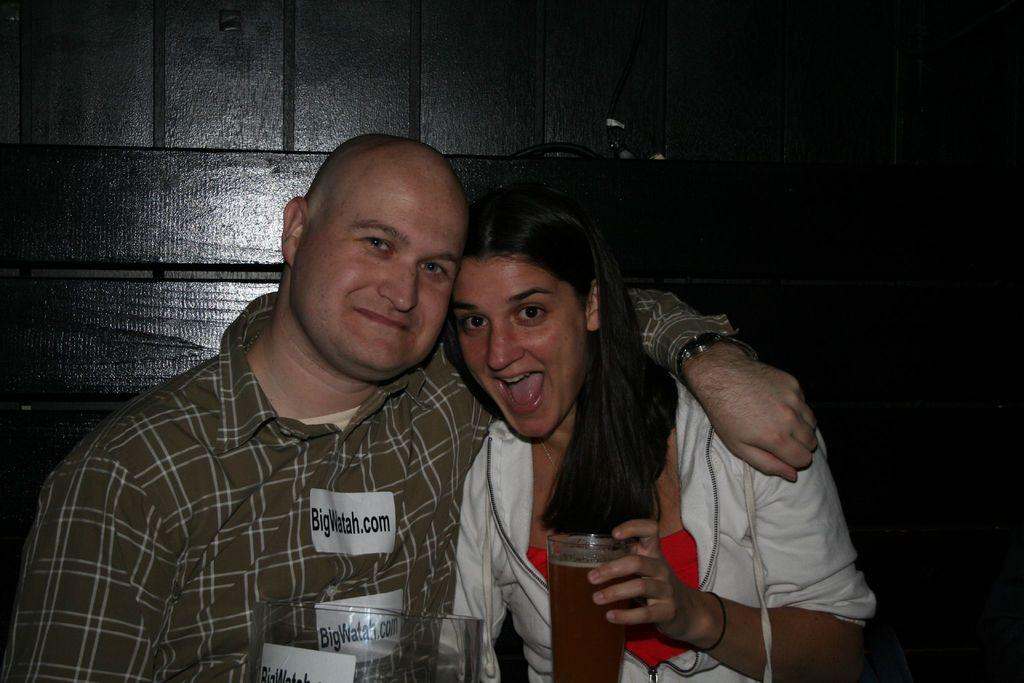How many people are present in the image? There are two persons in the image. What can be seen in the image besides the people? There is a glass and other objects visible in the image. What type of objects can be seen in the background of the image? There are wooden objects and a wall in the background of the image. Can you describe the unspecified object in the background? Unfortunately, the fact provided does not give enough information to describe the unspecified object in the background. What is the tendency of the stick in the image? There is no stick present in the image, so it is not possible to determine its tendency. 